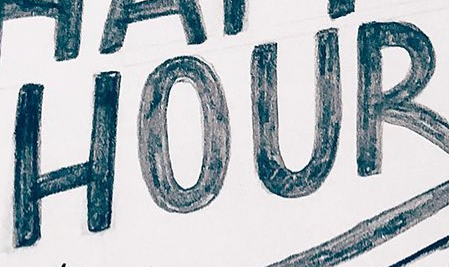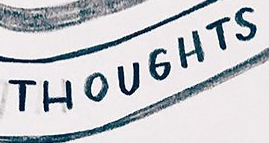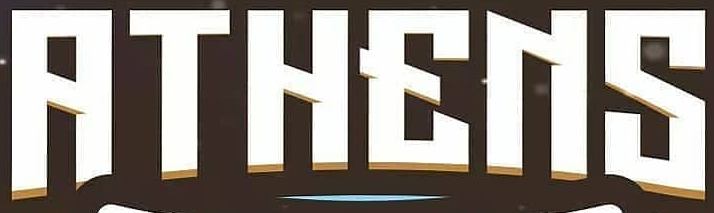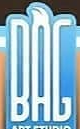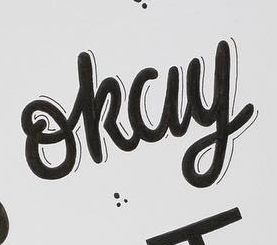Read the text content from these images in order, separated by a semicolon. HOUR; THOUGHTS; RTHENS; BAG; okay 